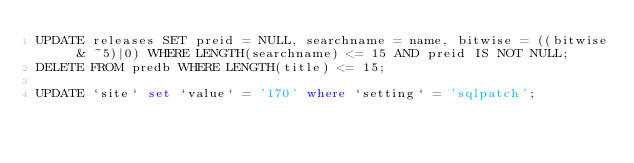<code> <loc_0><loc_0><loc_500><loc_500><_SQL_>UPDATE releases SET preid = NULL, searchname = name, bitwise = ((bitwise & ~5)|0) WHERE LENGTH(searchname) <= 15 AND preid IS NOT NULL;
DELETE FROM predb WHERE LENGTH(title) <= 15;

UPDATE `site` set `value` = '170' where `setting` = 'sqlpatch';
</code> 